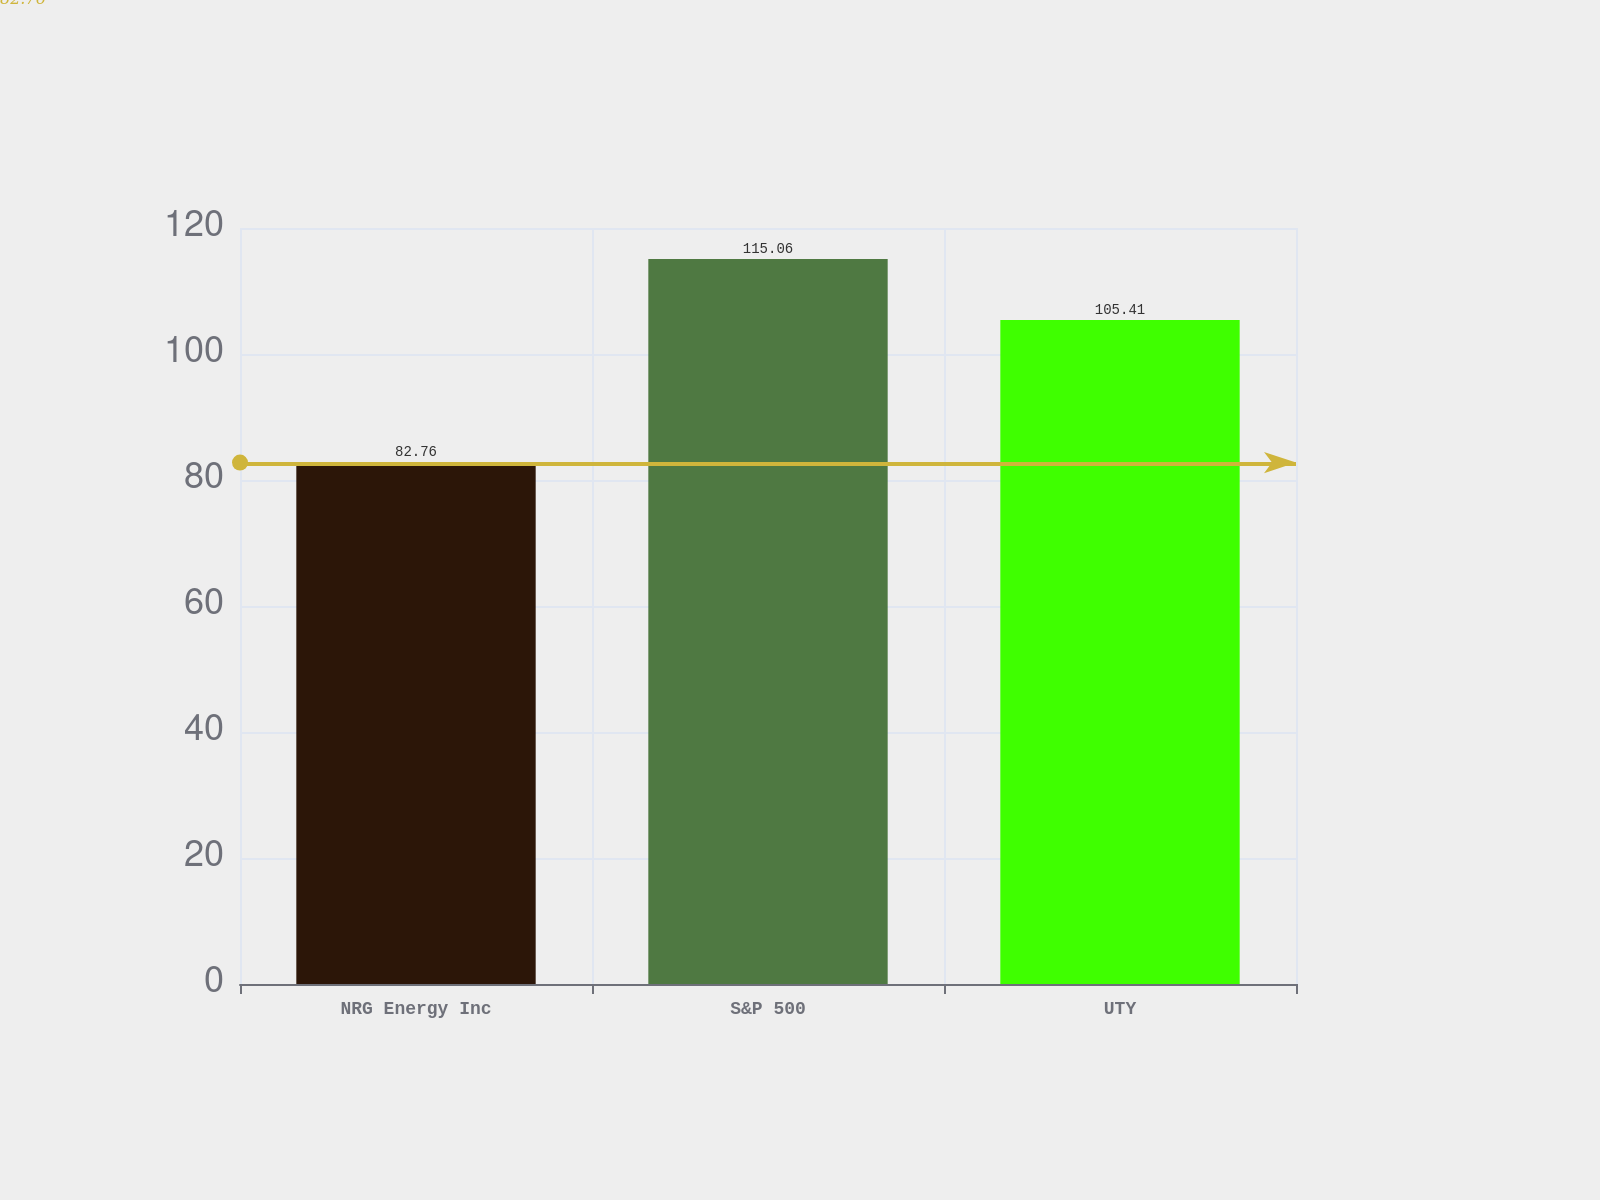Convert chart to OTSL. <chart><loc_0><loc_0><loc_500><loc_500><bar_chart><fcel>NRG Energy Inc<fcel>S&P 500<fcel>UTY<nl><fcel>82.76<fcel>115.06<fcel>105.41<nl></chart> 